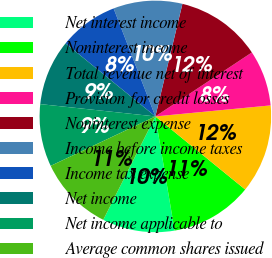Convert chart to OTSL. <chart><loc_0><loc_0><loc_500><loc_500><pie_chart><fcel>Net interest income<fcel>Noninterest income<fcel>Total revenue net of interest<fcel>Provision for credit losses<fcel>Noninterest expense<fcel>Income before income taxes<fcel>Income tax expense<fcel>Net income<fcel>Net income applicable to<fcel>Average common shares issued<nl><fcel>10.09%<fcel>11.47%<fcel>12.39%<fcel>7.8%<fcel>11.93%<fcel>9.63%<fcel>8.26%<fcel>9.17%<fcel>8.72%<fcel>10.55%<nl></chart> 